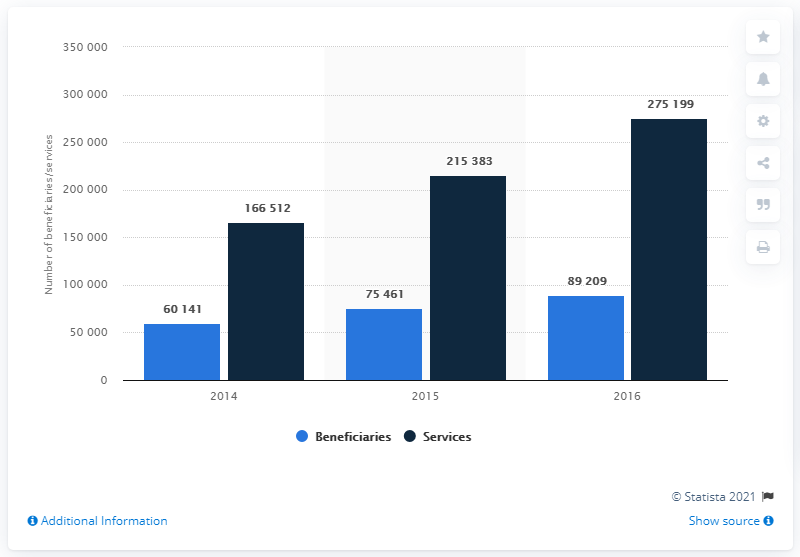Give some essential details in this illustration. In 2016, a total of 892,090 Medicare beneficiaries used telehealth services. In 2016, there were 275,199 Medicare beneficiaries who used telehealth services. 